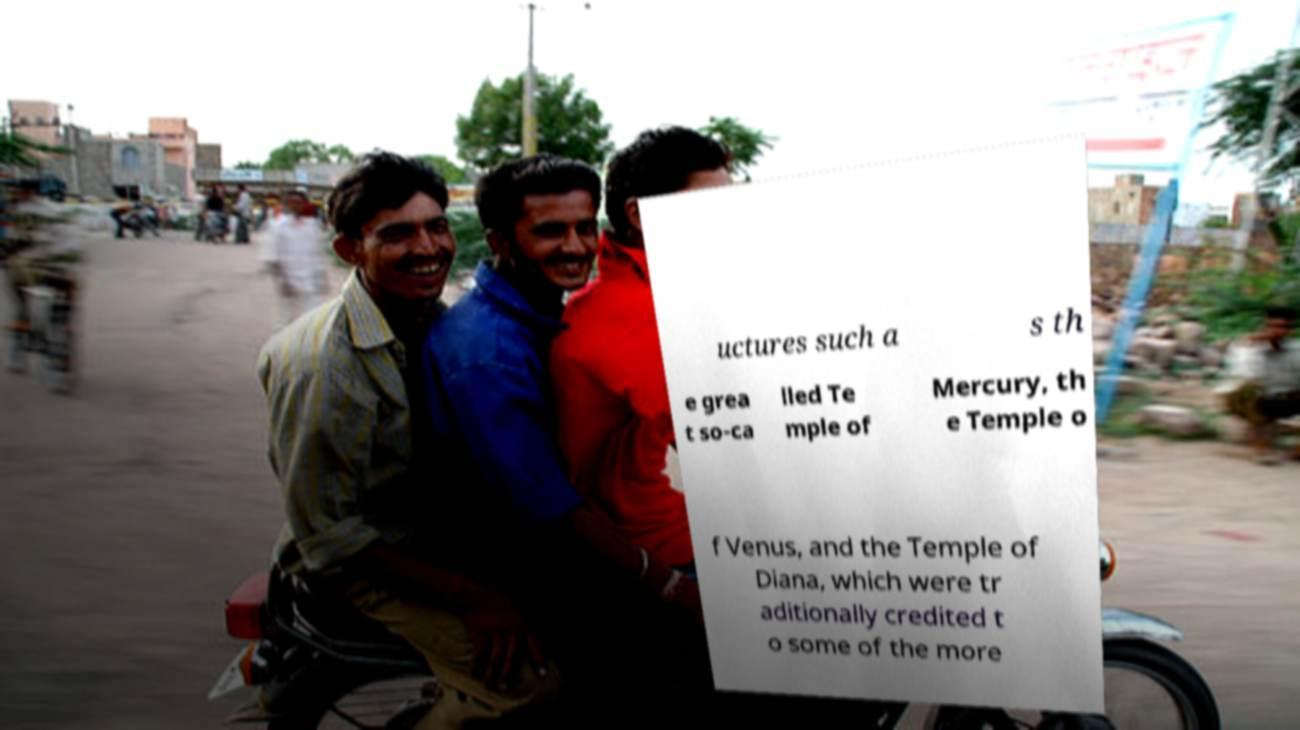What messages or text are displayed in this image? I need them in a readable, typed format. uctures such a s th e grea t so-ca lled Te mple of Mercury, th e Temple o f Venus, and the Temple of Diana, which were tr aditionally credited t o some of the more 